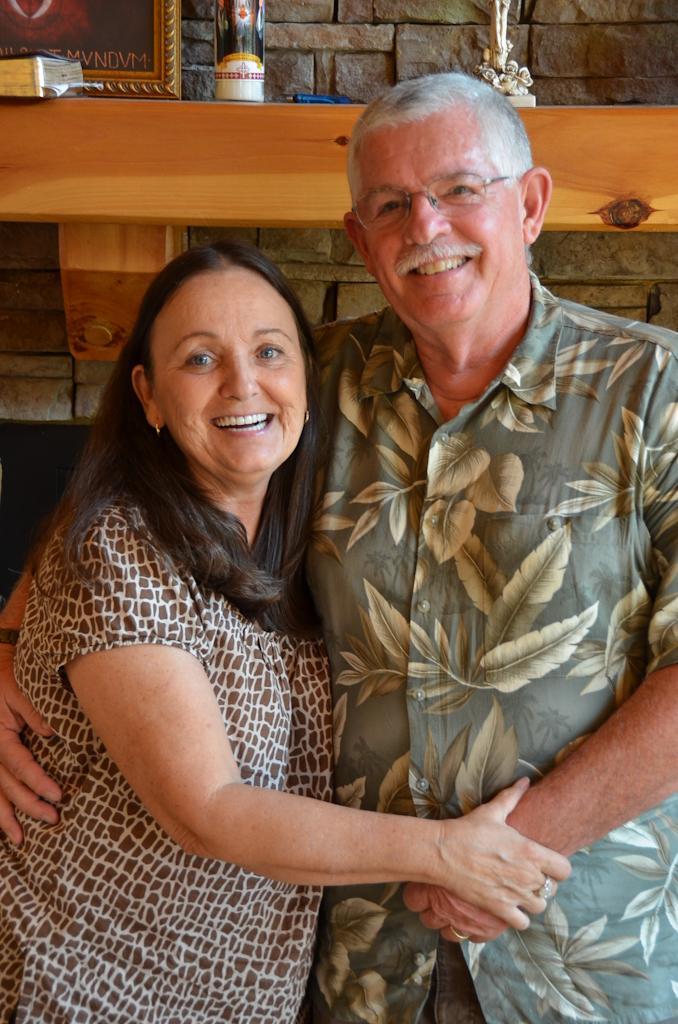Can you describe this image briefly? In this picture we can see a man and woman, they both are smiling, behind them we can see a frame and few other things on the shelf. 